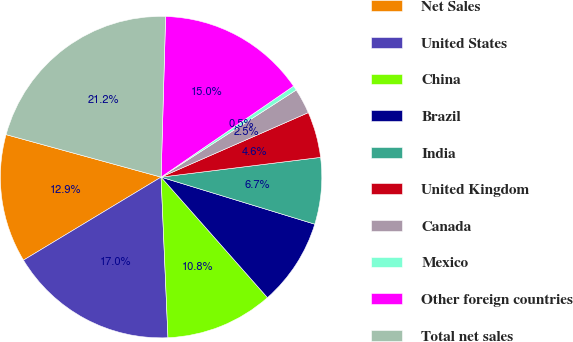Convert chart. <chart><loc_0><loc_0><loc_500><loc_500><pie_chart><fcel>Net Sales<fcel>United States<fcel>China<fcel>Brazil<fcel>India<fcel>United Kingdom<fcel>Canada<fcel>Mexico<fcel>Other foreign countries<fcel>Total net sales<nl><fcel>12.9%<fcel>17.04%<fcel>10.83%<fcel>8.76%<fcel>6.69%<fcel>4.61%<fcel>2.54%<fcel>0.47%<fcel>14.97%<fcel>21.19%<nl></chart> 